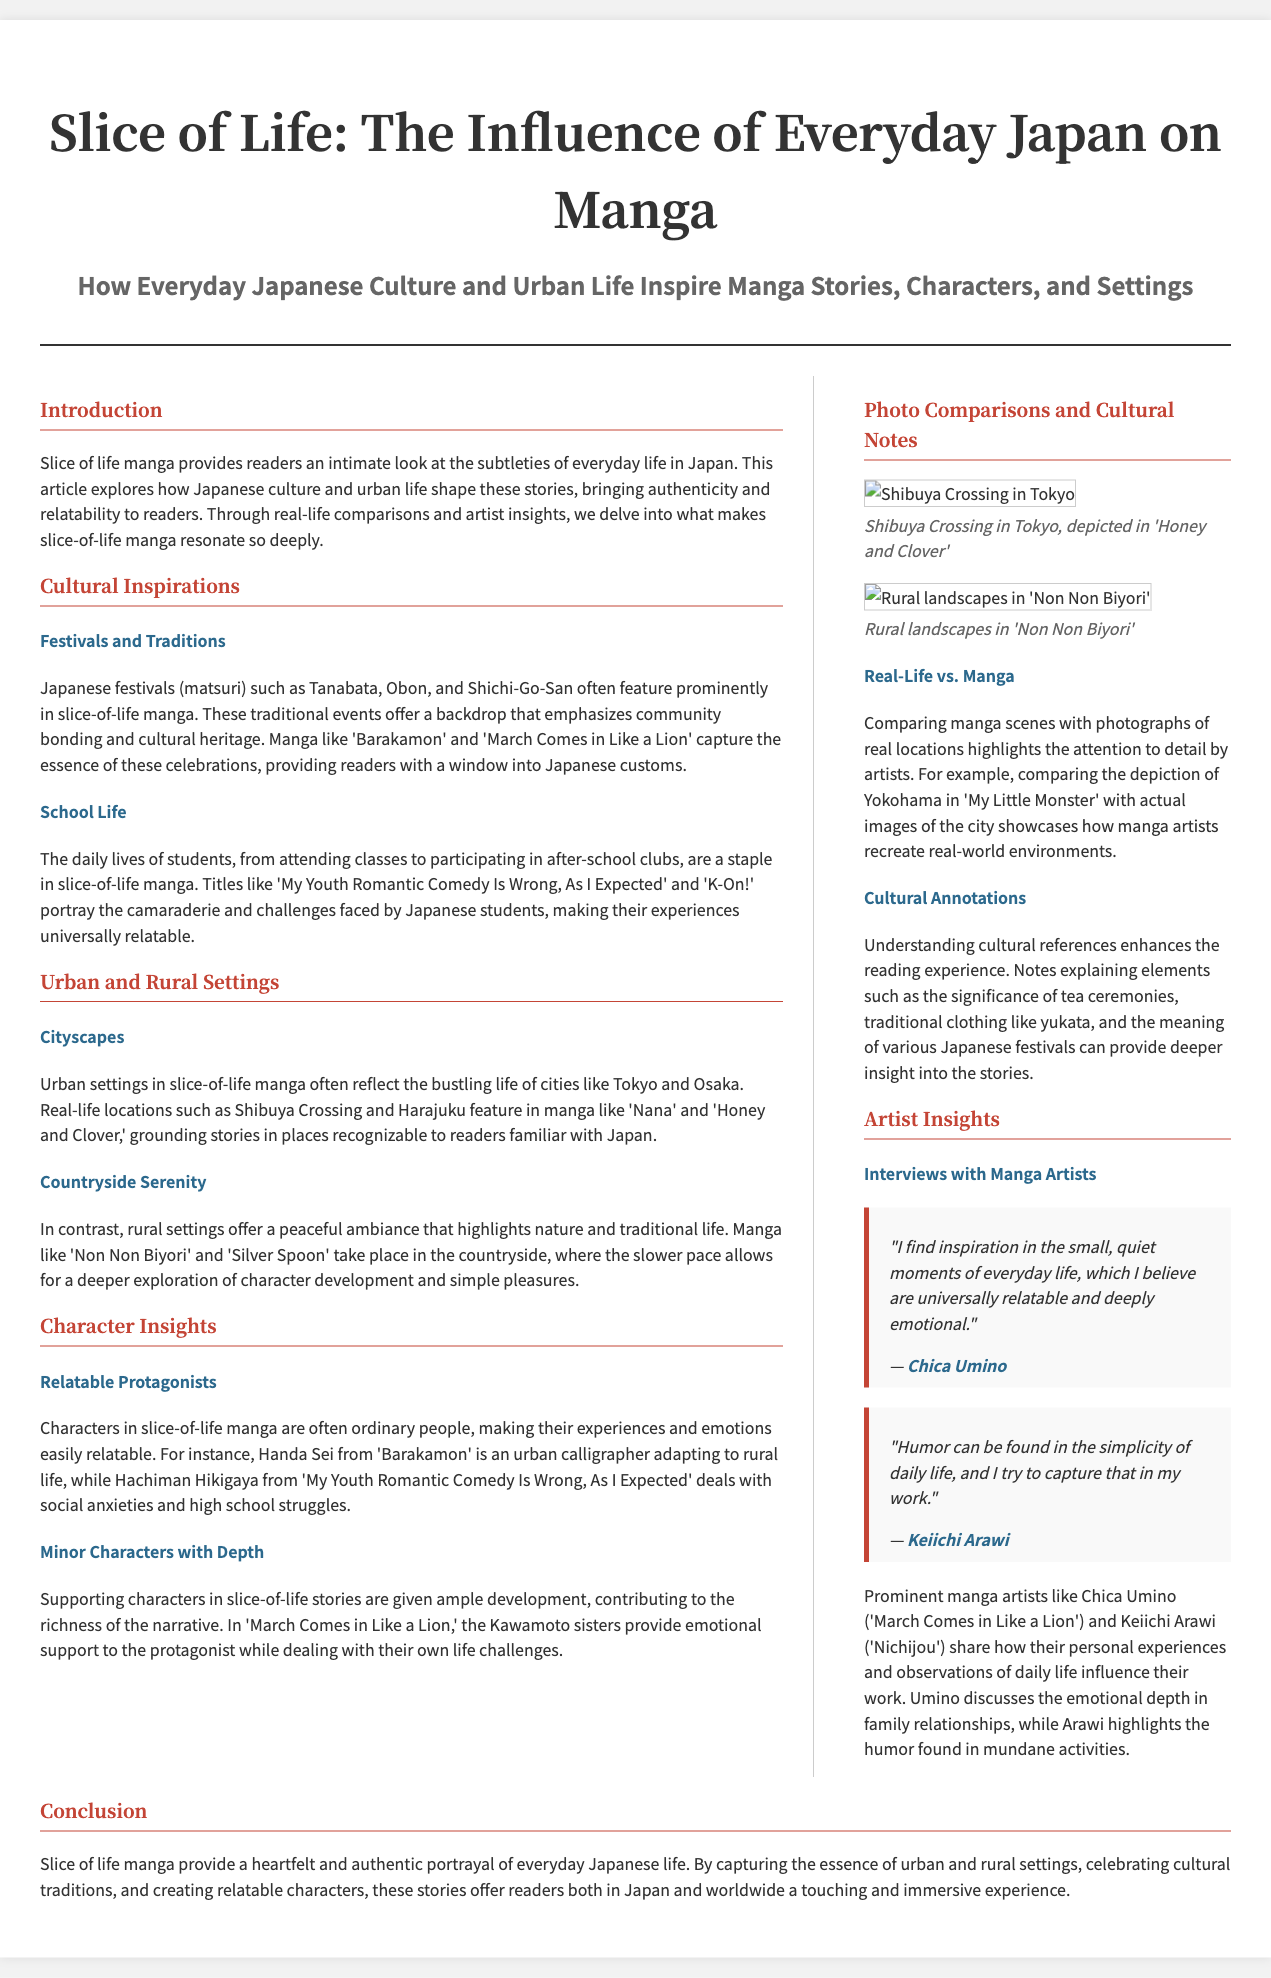What is the title of the article? The title of the article is displayed prominently at the top of the document.
Answer: Slice of Life: The Influence of Everyday Japan on Manga Who is the artist of the quote about inspiration in everyday life? The quote regarding inspiration in everyday life is attributed to a specific artist mentioned in the document.
Answer: Chica Umino Which manga is referenced in relation to rural landscapes? The section covering rural settings specifically names a manga that showcases countryside life.
Answer: Non Non Biyori What urban location is depicted in the art from 'Honey and Clover'? The document provides a real-life comparison related to a specific urban location featured in one of the manga.
Answer: Shibuya Crossing What cultural event is mentioned alongside community bonding in slice-of-life manga? A specific cultural event is highlighted as significant to community bonding featured in the stories.
Answer: Matsuri How do the characters in slice-of-life manga typically relate to readers? The document explains how character traits or backgrounds resonate with readers on an emotional level.
Answer: Ordinary people What kind of settings are contrasted in the discussion of slice-of-life manga? The document outlines different environments that form the backdrop for these stories.
Answer: Urban and rural settings Which popular title is mentioned for portraying school life? The section discussing student experiences in slice-of-life manga refers to a specific title.
Answer: My Youth Romantic Comedy Is Wrong, As I Expected What is the primary focus of the article? The article's main theme is summarized in the opening section regarding its content.
Answer: Everyday Japanese culture and urban life 